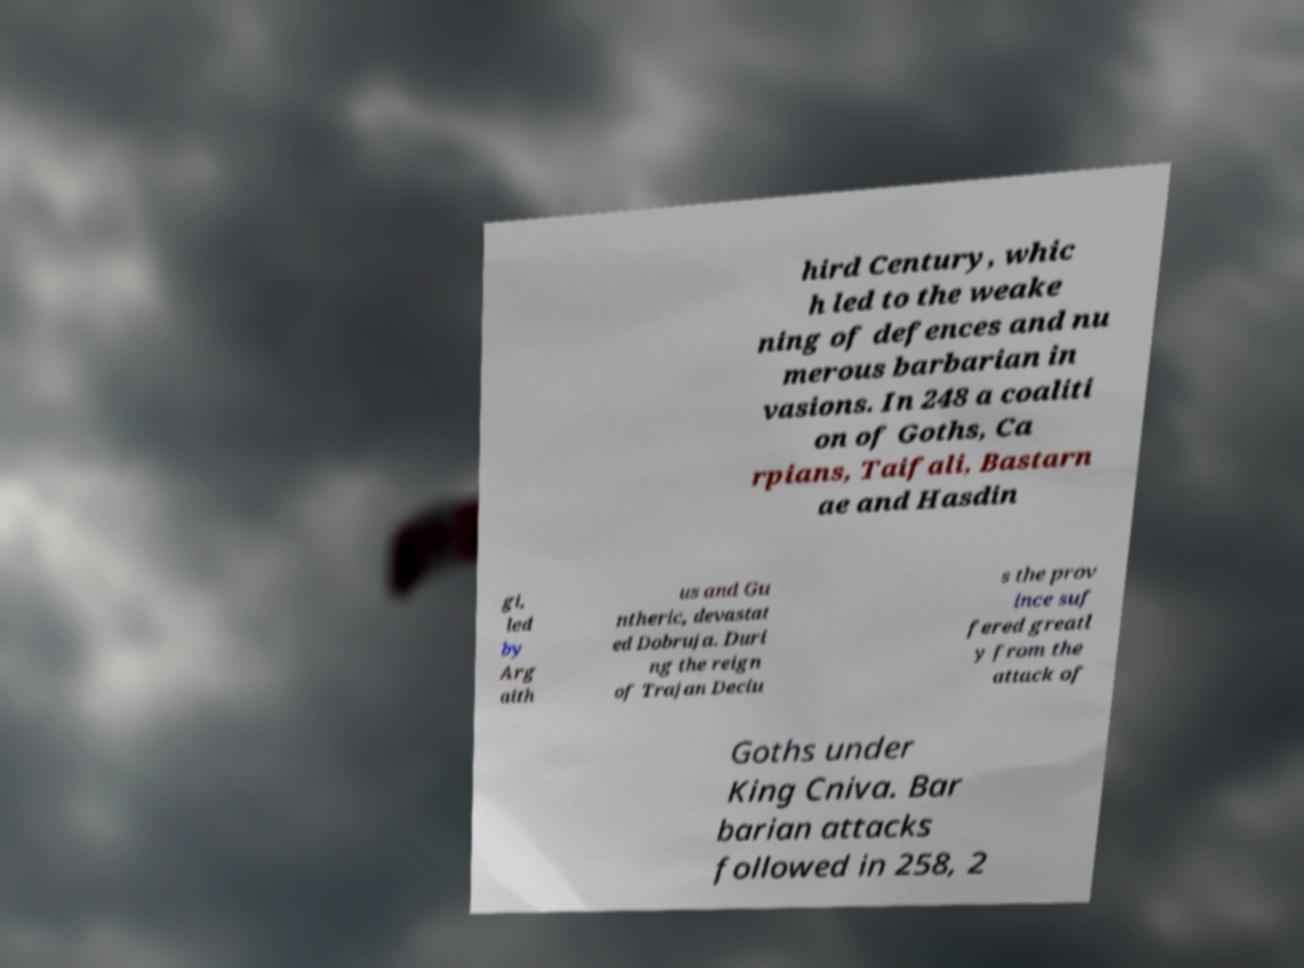What messages or text are displayed in this image? I need them in a readable, typed format. hird Century, whic h led to the weake ning of defences and nu merous barbarian in vasions. In 248 a coaliti on of Goths, Ca rpians, Taifali, Bastarn ae and Hasdin gi, led by Arg aith us and Gu ntheric, devastat ed Dobruja. Duri ng the reign of Trajan Deciu s the prov ince suf fered greatl y from the attack of Goths under King Cniva. Bar barian attacks followed in 258, 2 